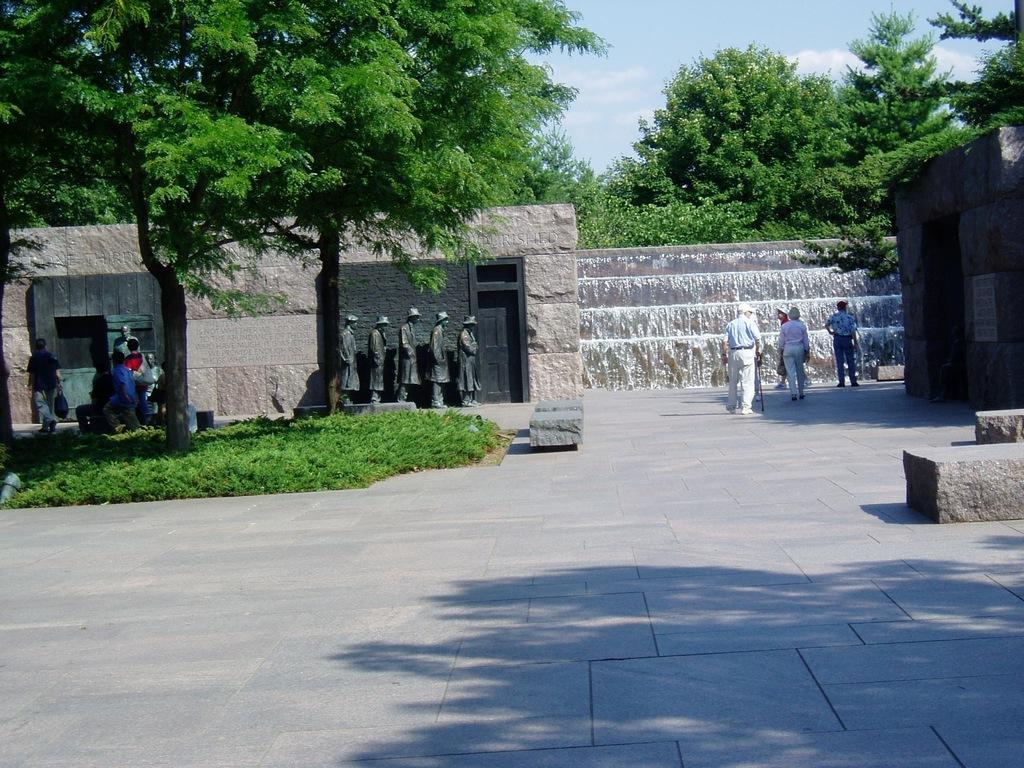Could you give a brief overview of what you see in this image? There are people, statues and walls in the foreground area of the image, it seems like waterfalls, trees and the sky in the background. 